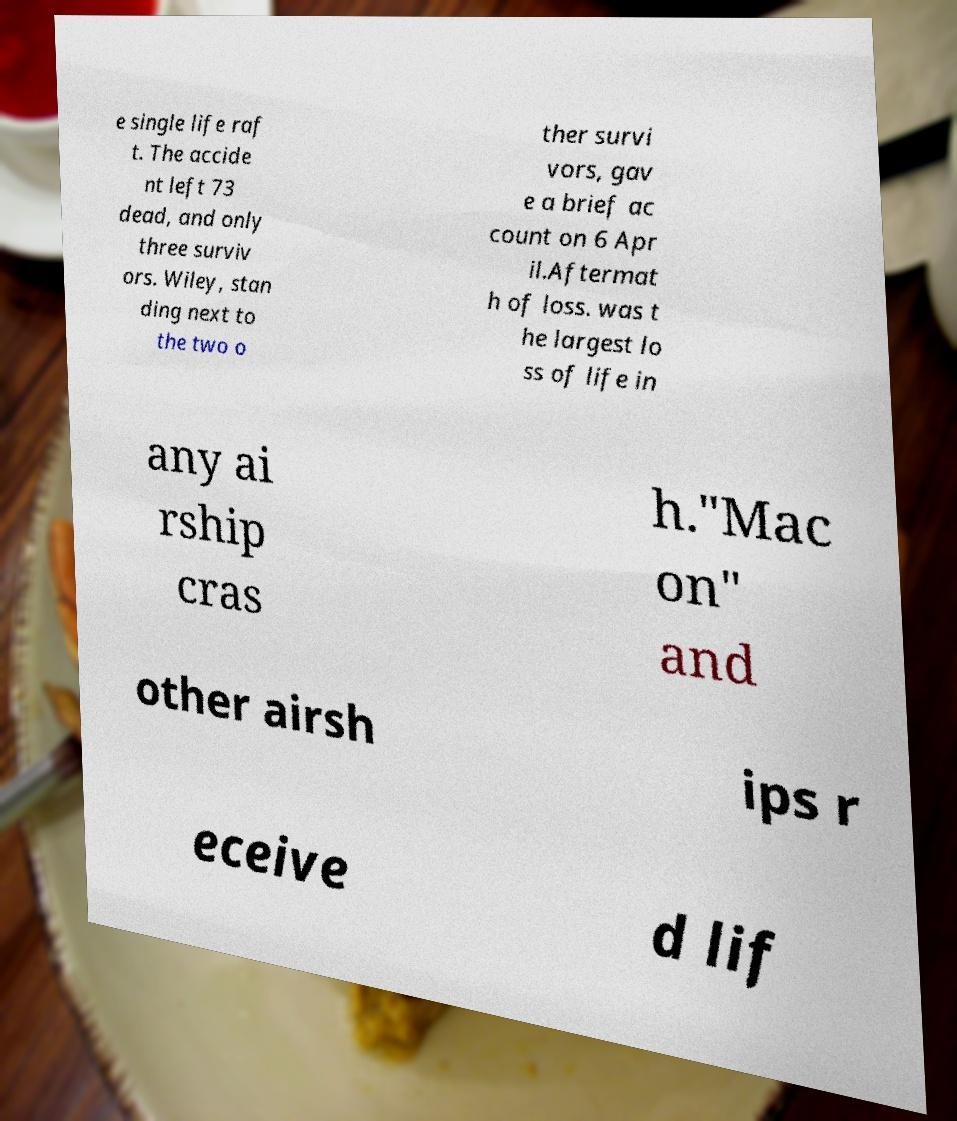Could you extract and type out the text from this image? e single life raf t. The accide nt left 73 dead, and only three surviv ors. Wiley, stan ding next to the two o ther survi vors, gav e a brief ac count on 6 Apr il.Aftermat h of loss. was t he largest lo ss of life in any ai rship cras h."Mac on" and other airsh ips r eceive d lif 